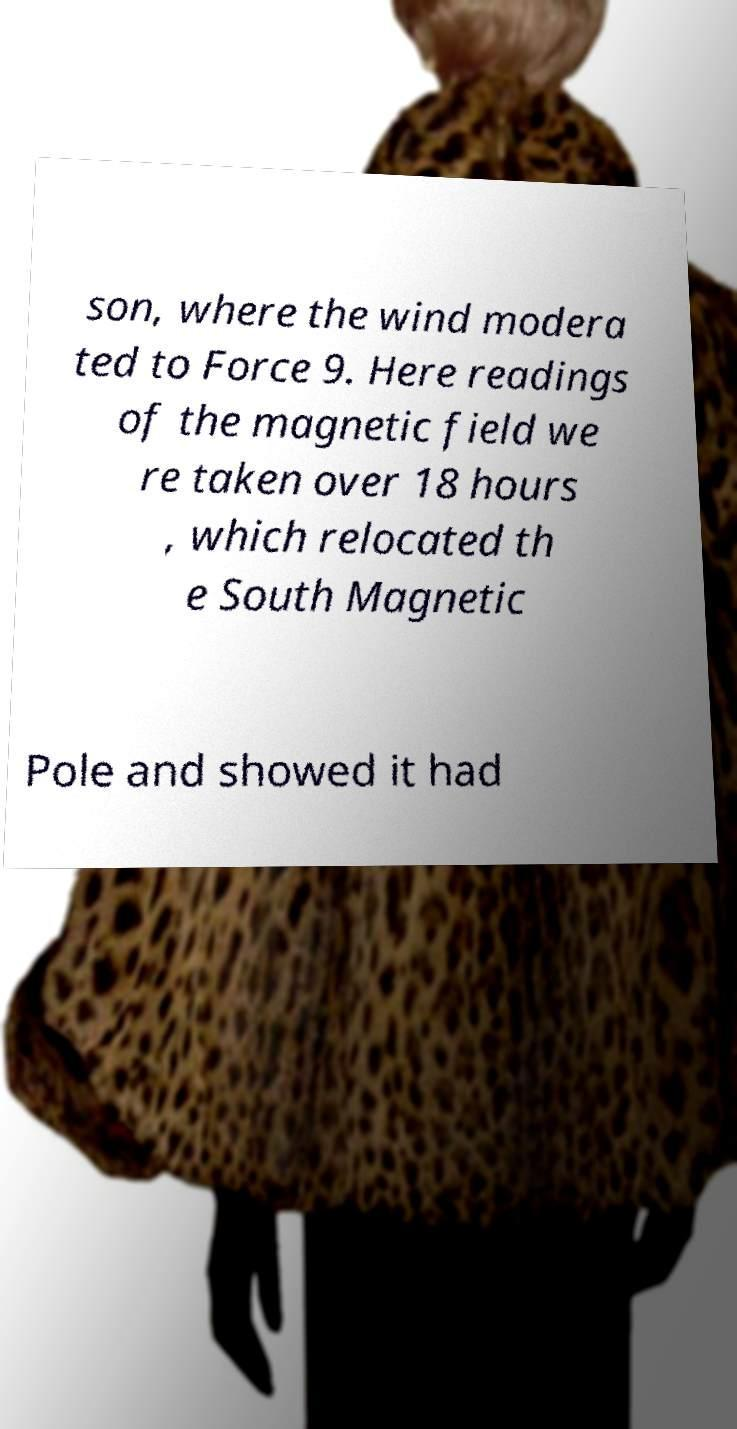Please read and relay the text visible in this image. What does it say? son, where the wind modera ted to Force 9. Here readings of the magnetic field we re taken over 18 hours , which relocated th e South Magnetic Pole and showed it had 